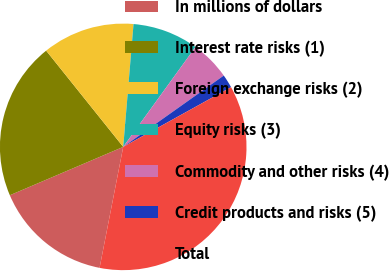Convert chart to OTSL. <chart><loc_0><loc_0><loc_500><loc_500><pie_chart><fcel>In millions of dollars<fcel>Interest rate risks (1)<fcel>Foreign exchange risks (2)<fcel>Equity risks (3)<fcel>Commodity and other risks (4)<fcel>Credit products and risks (5)<fcel>Total<nl><fcel>15.51%<fcel>20.67%<fcel>12.08%<fcel>8.64%<fcel>5.21%<fcel>1.77%<fcel>36.12%<nl></chart> 